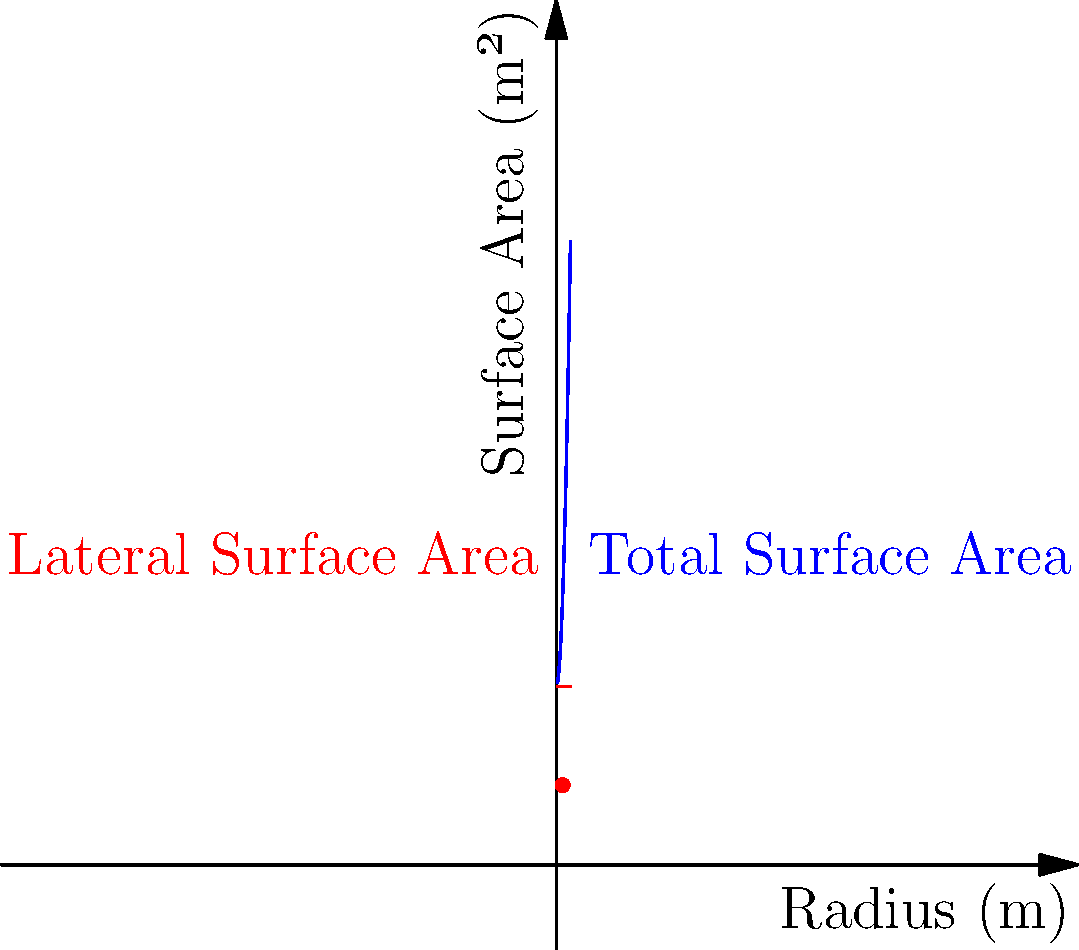A cylindrical pressure vessel needs to contain a volume of $10 \text{ m}^3$. The vessel consists of a cylindrical body and two circular end caps. To minimize material usage, we need to optimize the dimensions. If $r$ is the radius and $h$ is the height of the cylinder, which of the following statements is correct about the optimal dimensions?

a) $r = h$
b) $r = \frac{h}{2}$
c) $r = 2h$
d) $r = \sqrt{2}h$ Let's approach this step-by-step:

1) The volume of the cylinder is given by $V = \pi r^2 h = 10 \text{ m}^3$

2) The surface area of the cylinder (including end caps) is:
   $A = 2\pi r^2 + 2\pi rh$

3) We can express $h$ in terms of $r$ using the volume equation:
   $h = \frac{10}{\pi r^2}$

4) Substituting this into the surface area equation:
   $A = 2\pi r^2 + 2\pi r(\frac{10}{\pi r^2}) = 2\pi r^2 + \frac{20}{r}$

5) To find the minimum surface area, we differentiate $A$ with respect to $r$ and set it to zero:
   $\frac{dA}{dr} = 4\pi r - \frac{20}{r^2} = 0$

6) Solving this equation:
   $4\pi r^3 = 20$
   $r^3 = \frac{5}{\pi}$
   $r = \sqrt[3]{\frac{5}{\pi}}$

7) Now, let's find $h$:
   $h = \frac{10}{\pi r^2} = \frac{10}{\pi (\sqrt[3]{\frac{5}{\pi}})^2} = 2\sqrt[3]{\frac{5}{\pi}}$

8) Comparing $r$ and $h$:
   $\frac{r}{h} = \frac{\sqrt[3]{\frac{5}{\pi}}}{2\sqrt[3]{\frac{5}{\pi}}} = \frac{1}{2}$

Therefore, $r = \frac{h}{2}$
Answer: b) $r = \frac{h}{2}$ 